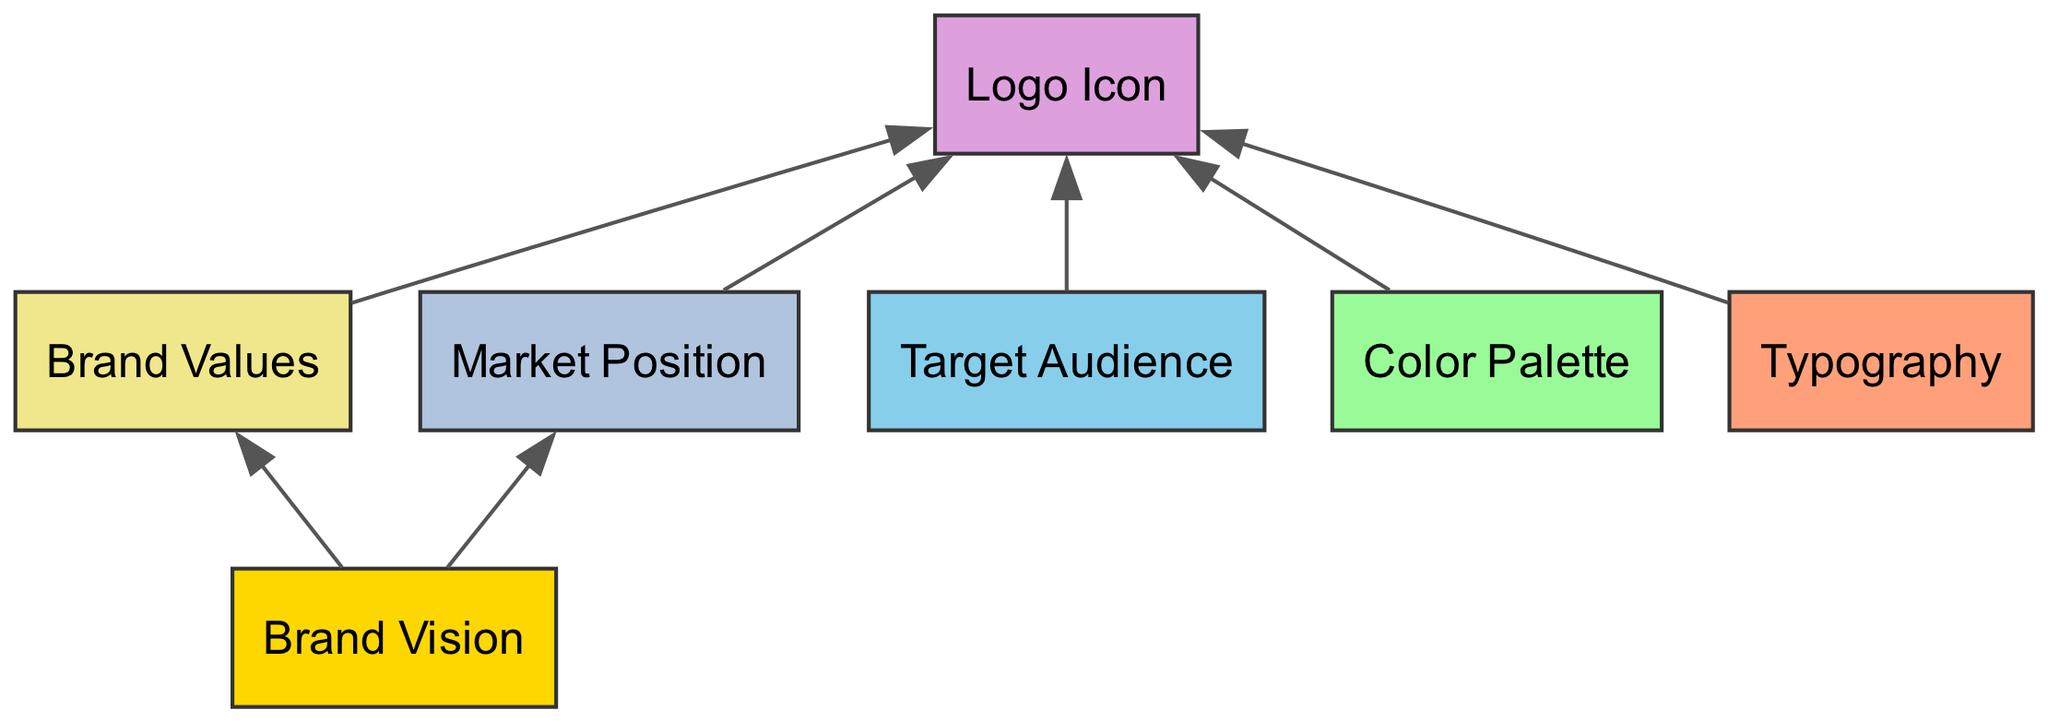What is the total number of nodes in the diagram? The diagram has seven nodes, which are Brand Vision, Target Audience, Color Palette, Typography, Logo Icon, Brand Values, and Market Position.
Answer: 7 Which node does the Brand Vision point to? The Brand Vision node points to the Brand Values and Market Position nodes, indicating its influence on both aspects.
Answer: Brand Values, Market Position How many edges are there in the diagram? By counting the connections between nodes, there are six edges that illustrate the relationships between Brand Vision, Target Audience, Color Palette, Typography, Brand Values, Market Position, and Logo Icon.
Answer: 6 Which element is the final target of all connections? The Logo Icon is the final target node, receiving inputs from Target Audience, Color Palette, Typography, Brand Values, and Market Position.
Answer: Logo Icon From which nodes does the Logo Icon receive input? The Logo Icon receives input from Target Audience, Color Palette, Typography, Brand Values, and Market Position, showing how various brand identity components converge into the logo design.
Answer: Target Audience, Color Palette, Typography, Brand Values, Market Position What is the relationship between Brand Vision and Logo Icon? Brand Vision influences the Logo Icon indirectly through connections to Brand Values and Market Position, which also connect to the Logo Icon, showing the foundational role of the Brand Vision.
Answer: Indirect influence How many nodes are influenced by the target audience? The Target Audience directly influences the Logo Icon, indicating that it is the only node affected by this component in the diagram.
Answer: 1 Which component is at the top of the flow in the diagram? The Brand Vision is at the top of the flow, representing the foundational idea that shapes the overall brand identity.
Answer: Brand Vision What does the Color Palette influence in the diagram? The Color Palette influences the Logo Icon specifically, indicating the importance of color choices in logo design.
Answer: Logo Icon Which nodes are influenced by the Market Position? The Market Position influences the Logo Icon, illustrating how a brand's position in the market can shape its visual identity.
Answer: Logo Icon 